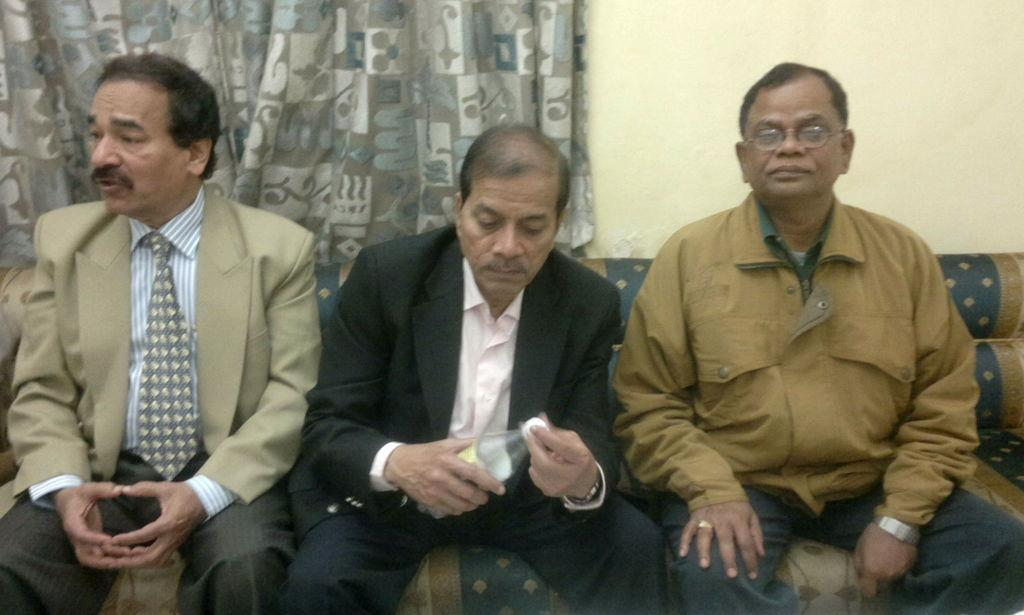What are the people in the image doing? The people in the image are sitting on a sofa. What can be seen hanging in the image? There is a curtain in the image. What color is the wall in the image? The wall in the image is cream-colored. What type of action is the bat performing in the image? There is no bat present in the image, so it is not possible to answer that question. 